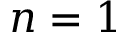Convert formula to latex. <formula><loc_0><loc_0><loc_500><loc_500>n = 1</formula> 